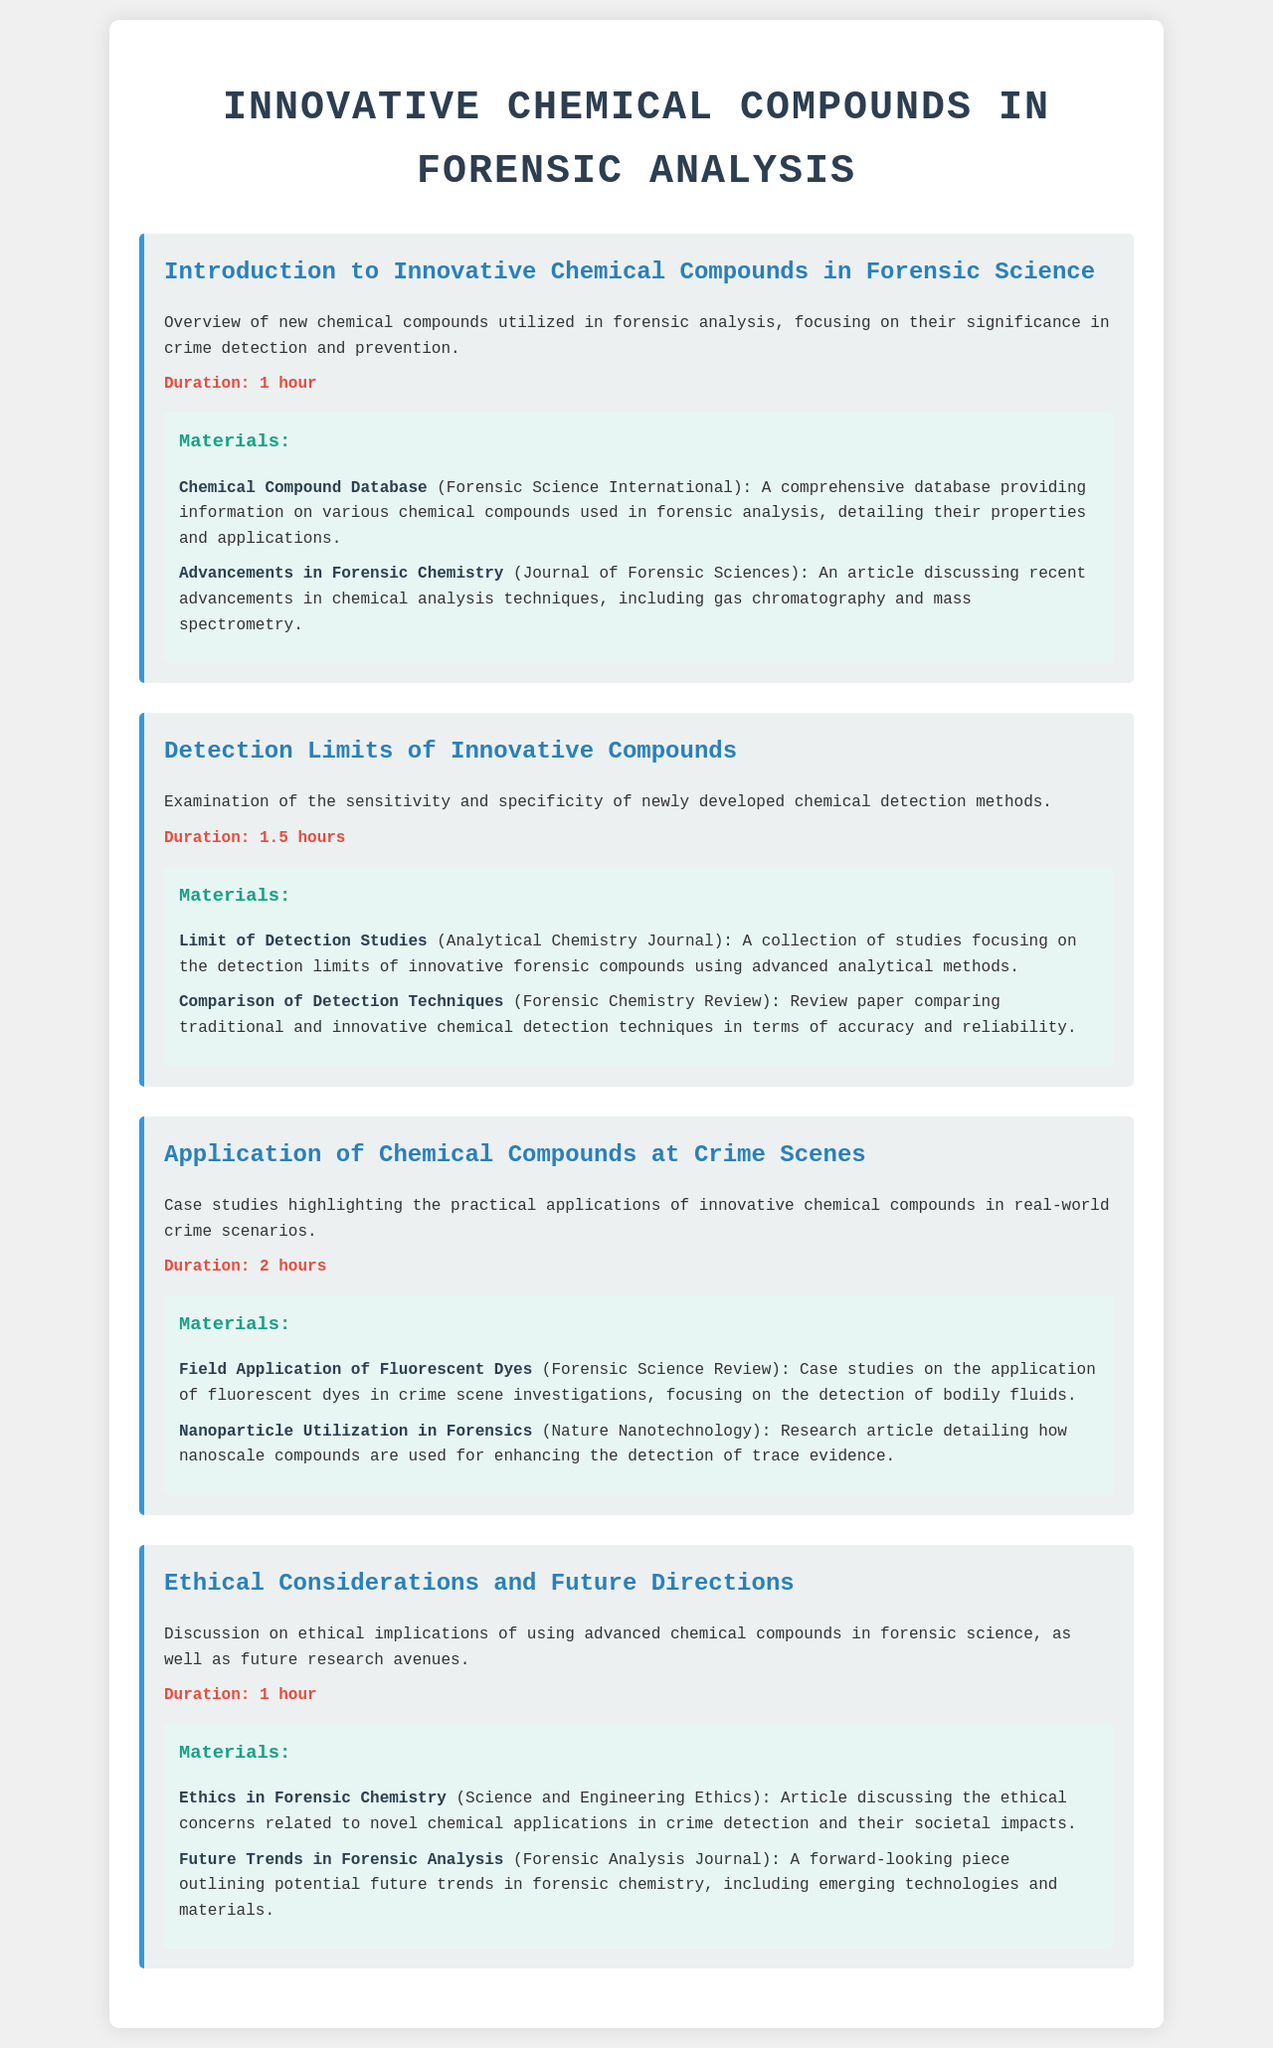What is the title of the schedule? The title is provided at the beginning of the document, which is "Innovative Chemical Compounds in Forensic Analysis."
Answer: Innovative Chemical Compounds in Forensic Analysis How long is the "Introduction to Innovative Chemical Compounds in Forensic Science" session? The duration of the session is specified clearly in the document.
Answer: 1 hour What type of materials are included in the "Detection Limits of Innovative Compounds" section? The document lists specific articles and studies as materials for each section.
Answer: Limit of Detection Studies, Comparison of Detection Techniques How many hours is dedicated to the "Application of Chemical Compounds at Crime Scenes"? The duration of the session is noted in the document.
Answer: 2 hours What is one of the ethical considerations discussed in the schedule? The document refers to ethical implications related to the use of advanced chemical compounds.
Answer: Ethical implications Who published the article "Ethics in Forensic Chemistry"? The document lists the sources of materials, including publication details.
Answer: Science and Engineering Ethics What is the focus of the "Field Application of Fluorescent Dyes" case studies? The document notes the focus of this case study as it pertains to crime scene investigations.
Answer: Detection of bodily fluids Which journal discusses "Future Trends in Forensic Analysis"? The document identifies the specific journal that publishes this piece.
Answer: Forensic Analysis Journal 